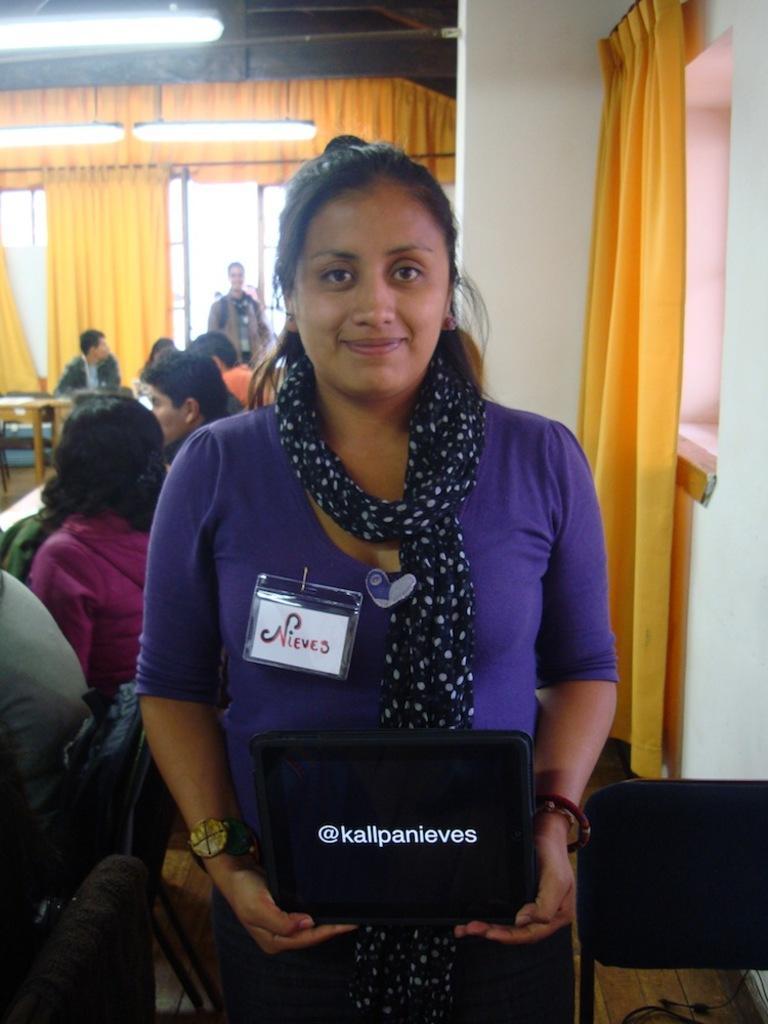In one or two sentences, can you explain what this image depicts? In this picture I can observe a woman standing on the floor wearing violet color dress. She is smiling. Behind her there are some people sitting on the chairs. In the background I can observe yellow color curtains and tube lights. 